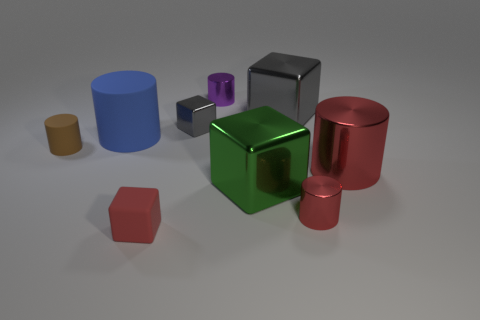Are there any shapes in the image that are the same color? Yes, there are multiple shapes in the image that share the same color. For instance, the large cube in the center has the same green color as the smaller cube seen in front of the purple cylinder. 